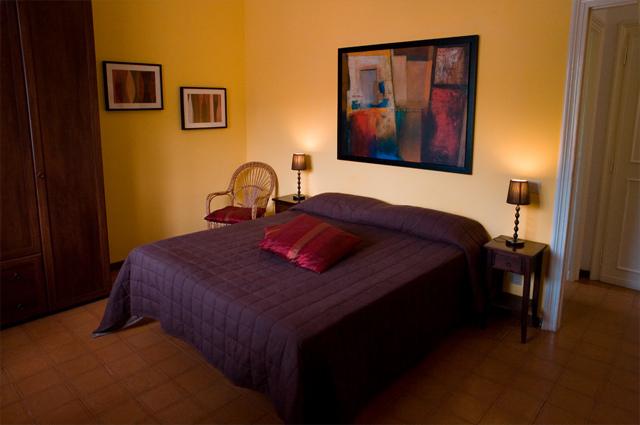How many lamps are in the room?
Be succinct. 2. What colors are the pillow?
Give a very brief answer. Red. How many pictures are hung on the wall in this scene?
Keep it brief. 3. What type of light bulb is in these two lamps?
Short answer required. Yellow. Is the floor carpeted?
Quick response, please. No. Is this a living room?
Short answer required. No. What color is the lamp shade?
Write a very short answer. Brown. 